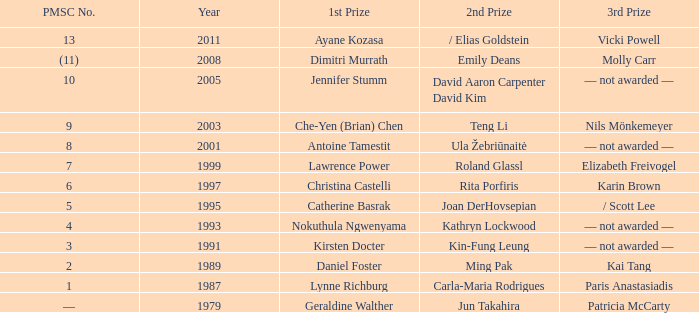What is the earliest year in which the 1st price went to Che-Yen (Brian) Chen? 2003.0. 